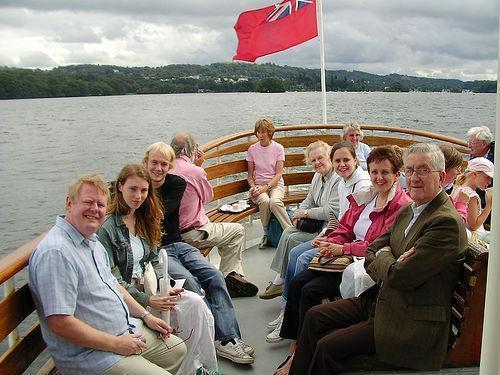How many small kids are on the boat?
Give a very brief answer. 1. How many people are in the photo?
Give a very brief answer. 10. How many white surfboards are there?
Give a very brief answer. 0. 